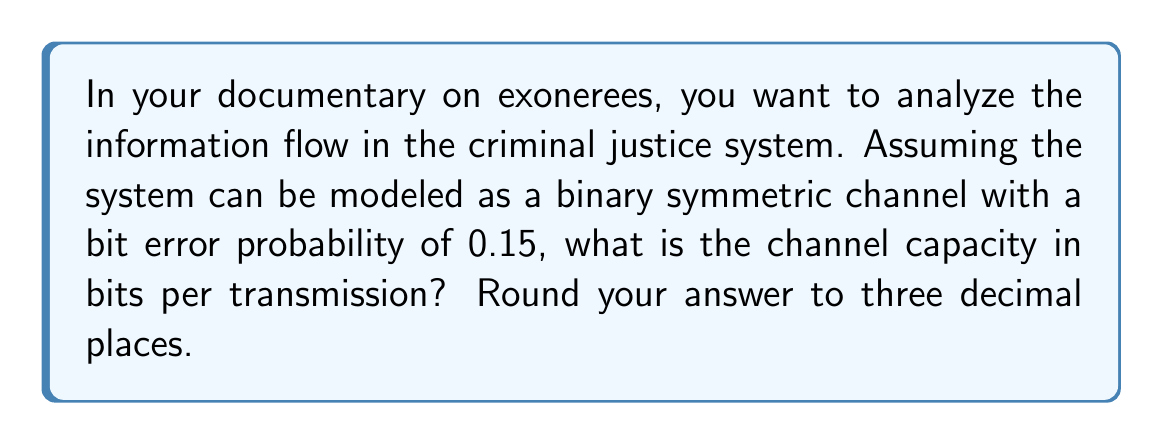Teach me how to tackle this problem. To solve this problem, we need to use the concept of channel capacity from information theory. For a binary symmetric channel (BSC), the channel capacity is given by:

$$C = 1 - H(p)$$

Where $C$ is the channel capacity, and $H(p)$ is the binary entropy function of the error probability $p$.

The binary entropy function is defined as:

$$H(p) = -p \log_2(p) - (1-p) \log_2(1-p)$$

Given:
- The bit error probability $p = 0.15$

Steps:
1) Calculate $H(p)$:
   $$H(0.15) = -0.15 \log_2(0.15) - 0.85 \log_2(0.85)$$
   
   Using a calculator:
   $$H(0.15) \approx 0.610$$

2) Calculate the channel capacity:
   $$C = 1 - H(0.15)$$
   $$C = 1 - 0.610$$
   $$C \approx 0.390$$

3) Round to three decimal places:
   $$C \approx 0.390$$ bits per transmission

This result indicates that in your model of the criminal justice system, despite the 15% error rate, about 39% of the information can still be reliably transmitted per use of the channel.
Answer: 0.390 bits per transmission 